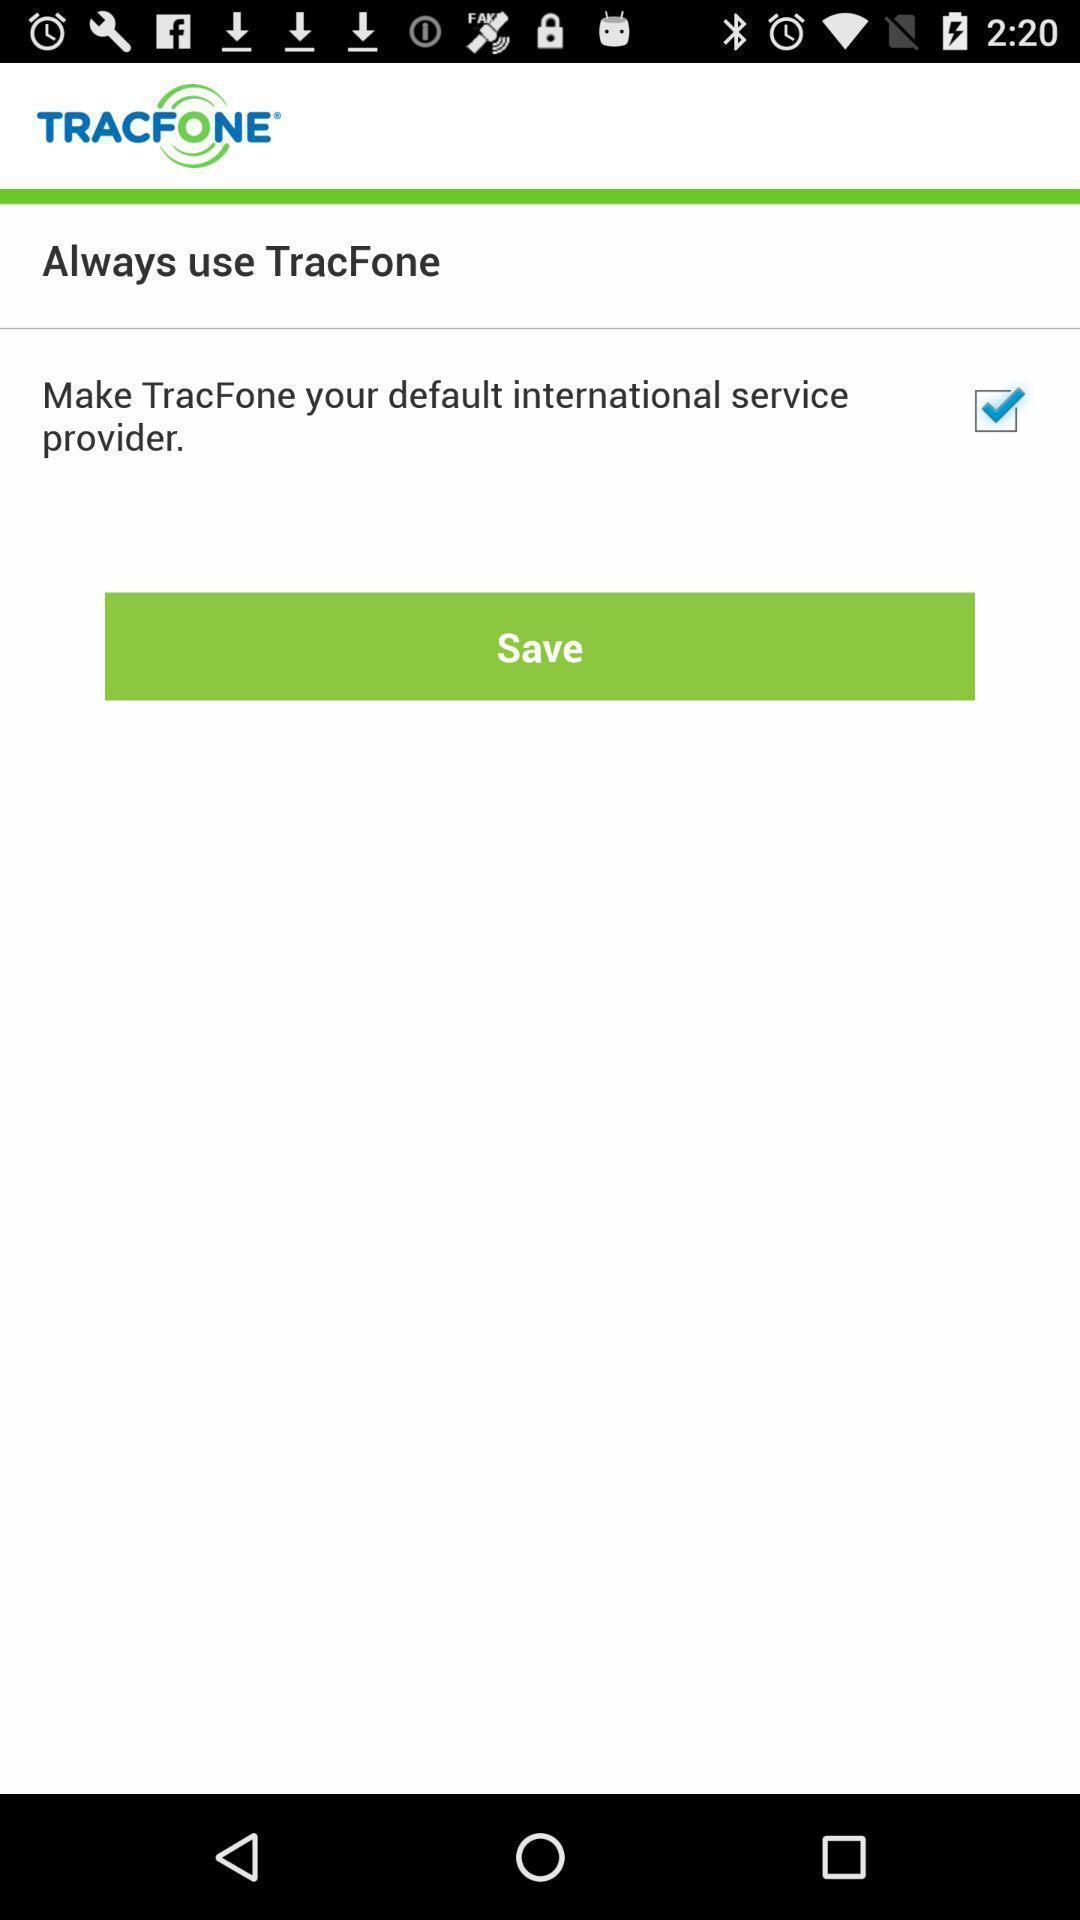Describe this image in words. Save option for default international service. 